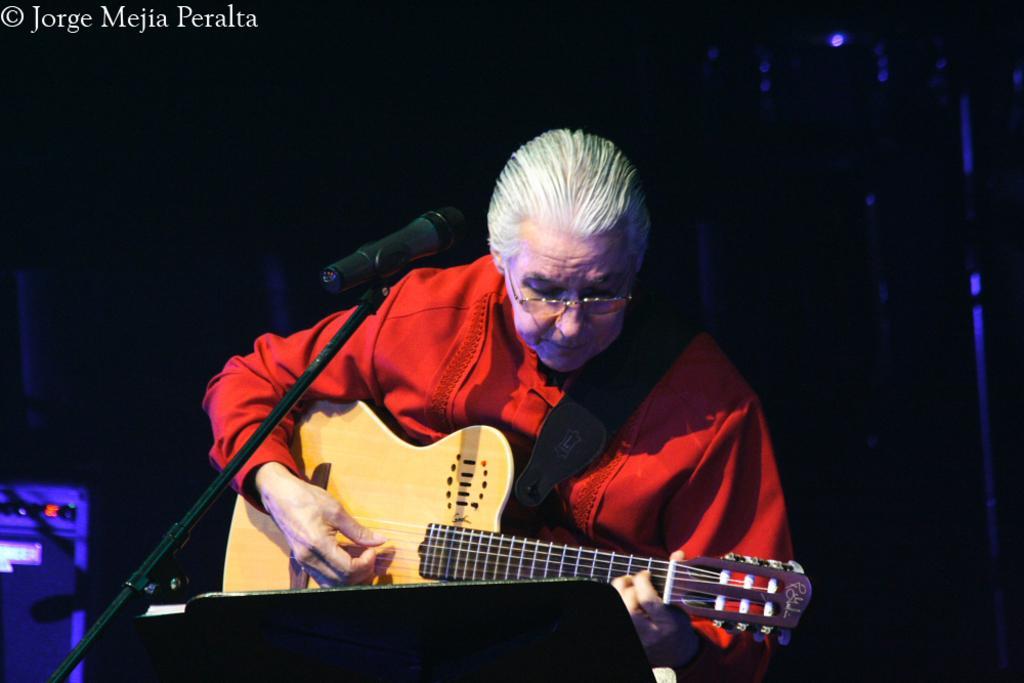Can you describe this image briefly? In this image i can see a person holding a guitar in his hands and i can see a microphone in front of him. 